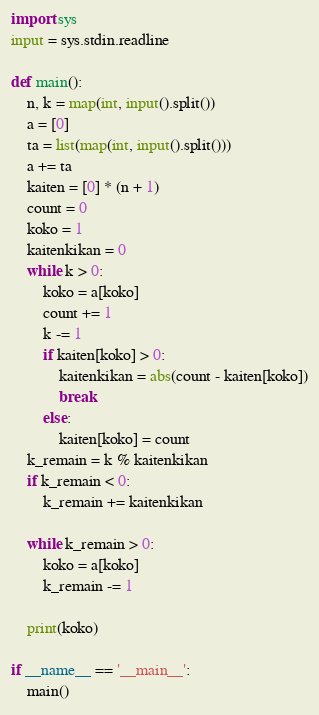Convert code to text. <code><loc_0><loc_0><loc_500><loc_500><_Python_>
import sys
input = sys.stdin.readline

def main():
    n, k = map(int, input().split())
    a = [0]
    ta = list(map(int, input().split()))
    a += ta
    kaiten = [0] * (n + 1)
    count = 0
    koko = 1
    kaitenkikan = 0
    while k > 0:
        koko = a[koko]
        count += 1
        k -= 1
        if kaiten[koko] > 0:
            kaitenkikan = abs(count - kaiten[koko])
            break
        else:
            kaiten[koko] = count
    k_remain = k % kaitenkikan
    if k_remain < 0:
        k_remain += kaitenkikan

    while k_remain > 0:
        koko = a[koko]
        k_remain -= 1

    print(koko)

if __name__ == '__main__':
    main()
</code> 